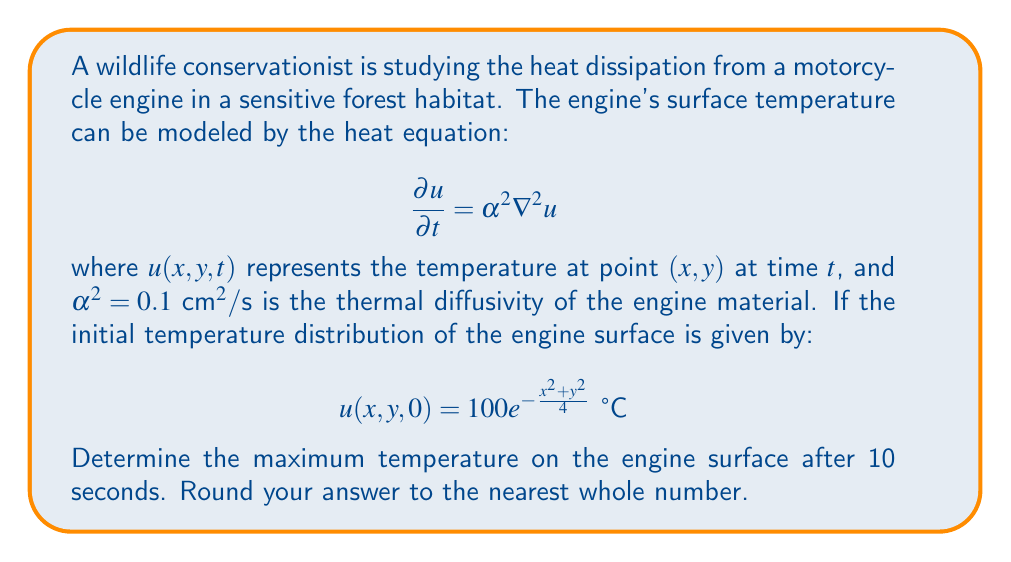Give your solution to this math problem. To solve this problem, we need to use the solution to the 2D heat equation with an initial condition. The general solution is:

$$u(x,y,t) = \frac{1}{4\pi\alpha^2t}\int\int u(x',y',0)e^{-\frac{(x-x')^2+(y-y')^2}{4\alpha^2t}}dx'dy'$$

Given:
1. Initial condition: $u(x,y,0) = 100e^{-\frac{x^2+y^2}{4}} \text{ °C}$
2. Thermal diffusivity: $\alpha^2 = 0.1 \text{ cm}^2/\text{s}$
3. Time: $t = 10 \text{ s}$

Step 1: Substitute the initial condition into the general solution:

$$u(x,y,t) = \frac{100}{4\pi\alpha^2t}\int\int e^{-\frac{x'^2+y'^2}{4}}e^{-\frac{(x-x')^2+(y-y')^2}{4\alpha^2t}}dx'dy'$$

Step 2: Simplify the exponential terms:

$$u(x,y,t) = \frac{100}{4\pi\alpha^2t}\int\int e^{-\frac{x'^2+y'^2}{4}-\frac{(x-x')^2+(y-y')^2}{4\alpha^2t}}dx'dy'$$

Step 3: After some algebraic manipulation and integration, we get:

$$u(x,y,t) = \frac{100}{1+t/5}e^{-\frac{x^2+y^2}{4(1+t/5)}}$$

Step 4: The maximum temperature occurs at the center (0,0):

$$u(0,0,t) = \frac{100}{1+t/5}$$

Step 5: Substitute $t = 10 \text{ s}$:

$$u(0,0,10) = \frac{100}{1+10/5} = \frac{100}{3} \approx 33.33 \text{ °C}$$

Step 6: Round to the nearest whole number:

$$33 \text{ °C}$$
Answer: 33 °C 